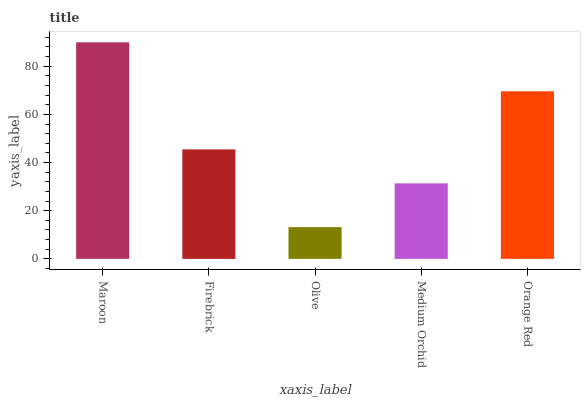Is Olive the minimum?
Answer yes or no. Yes. Is Maroon the maximum?
Answer yes or no. Yes. Is Firebrick the minimum?
Answer yes or no. No. Is Firebrick the maximum?
Answer yes or no. No. Is Maroon greater than Firebrick?
Answer yes or no. Yes. Is Firebrick less than Maroon?
Answer yes or no. Yes. Is Firebrick greater than Maroon?
Answer yes or no. No. Is Maroon less than Firebrick?
Answer yes or no. No. Is Firebrick the high median?
Answer yes or no. Yes. Is Firebrick the low median?
Answer yes or no. Yes. Is Medium Orchid the high median?
Answer yes or no. No. Is Maroon the low median?
Answer yes or no. No. 